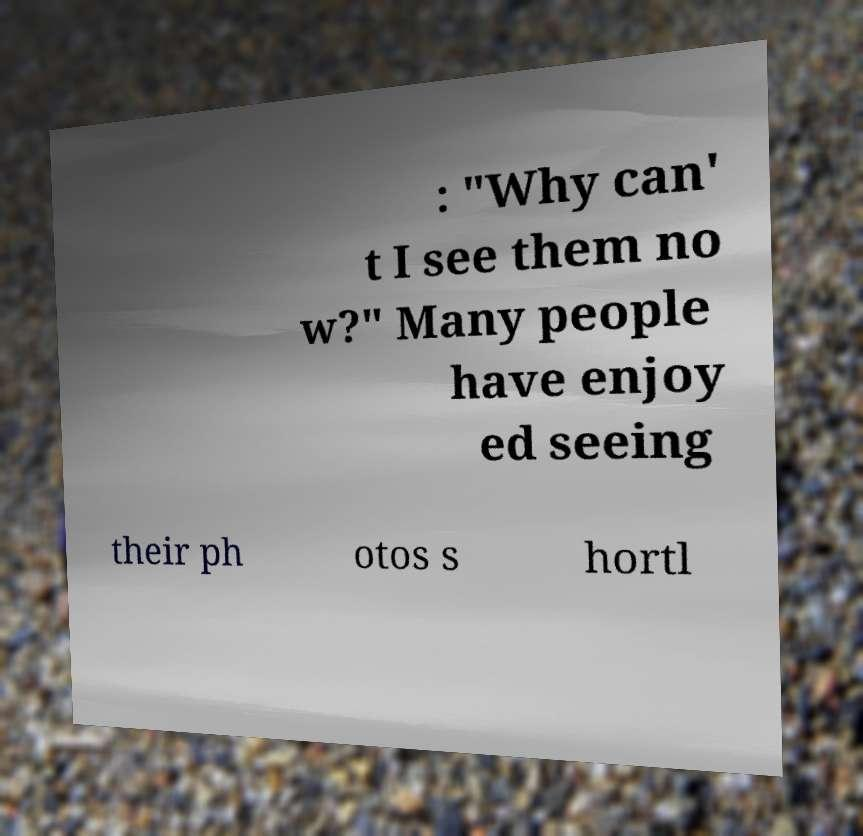For documentation purposes, I need the text within this image transcribed. Could you provide that? : "Why can' t I see them no w?" Many people have enjoy ed seeing their ph otos s hortl 